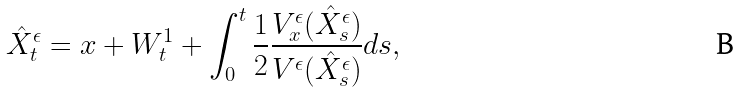<formula> <loc_0><loc_0><loc_500><loc_500>\hat { X } _ { t } ^ { \epsilon } = x + W _ { t } ^ { 1 } + \int _ { 0 } ^ { t } \frac { 1 } { 2 } \frac { V ^ { \epsilon } _ { x } ( \hat { X } _ { s } ^ { \epsilon } ) } { V ^ { \epsilon } ( \hat { X } _ { s } ^ { \epsilon } ) } d s ,</formula> 